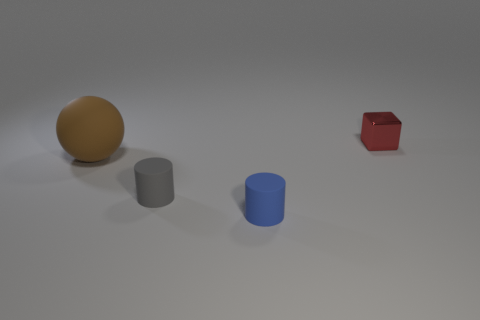Is there any other thing that is the same material as the tiny red block?
Your answer should be compact. No. There is a object that is behind the brown rubber ball; what is its shape?
Provide a succinct answer. Cube. What is the material of the tiny blue cylinder?
Offer a terse response. Rubber. There is a cube that is the same size as the blue rubber thing; what is its color?
Make the answer very short. Red. Is the tiny blue object the same shape as the big brown rubber thing?
Your response must be concise. No. What is the material of the thing that is both right of the gray object and to the left of the tiny metallic block?
Ensure brevity in your answer.  Rubber. How big is the red block?
Give a very brief answer. Small. What color is the other matte thing that is the same shape as the small blue rubber thing?
Provide a succinct answer. Gray. Is there any other thing that is the same color as the large matte object?
Provide a succinct answer. No. Do the object that is behind the large brown sphere and the cylinder to the right of the small gray matte object have the same size?
Give a very brief answer. Yes. 